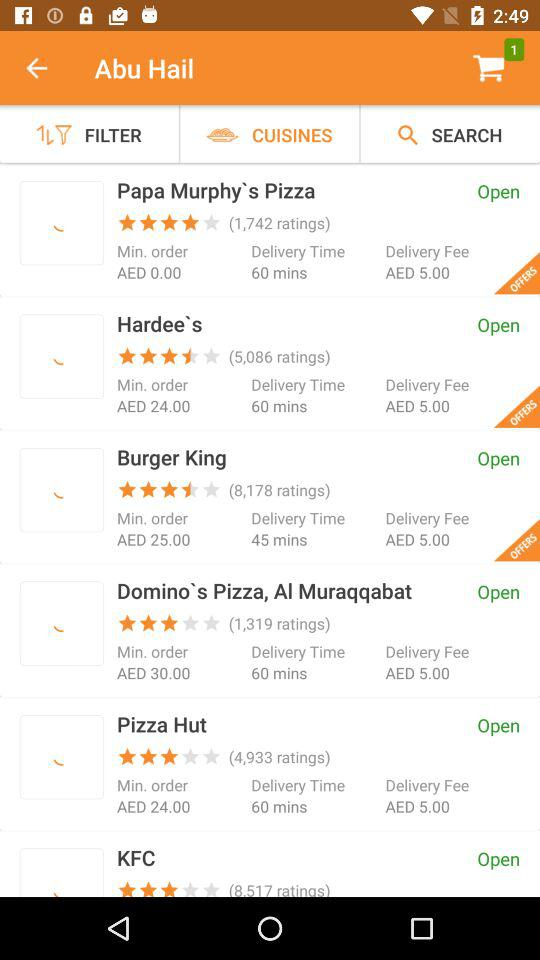What is the delivery time for "Burger King"? The delivery time is 45 minutes. 